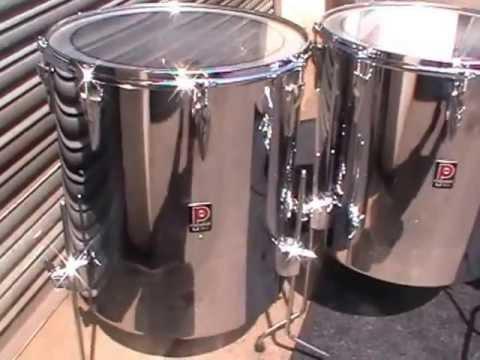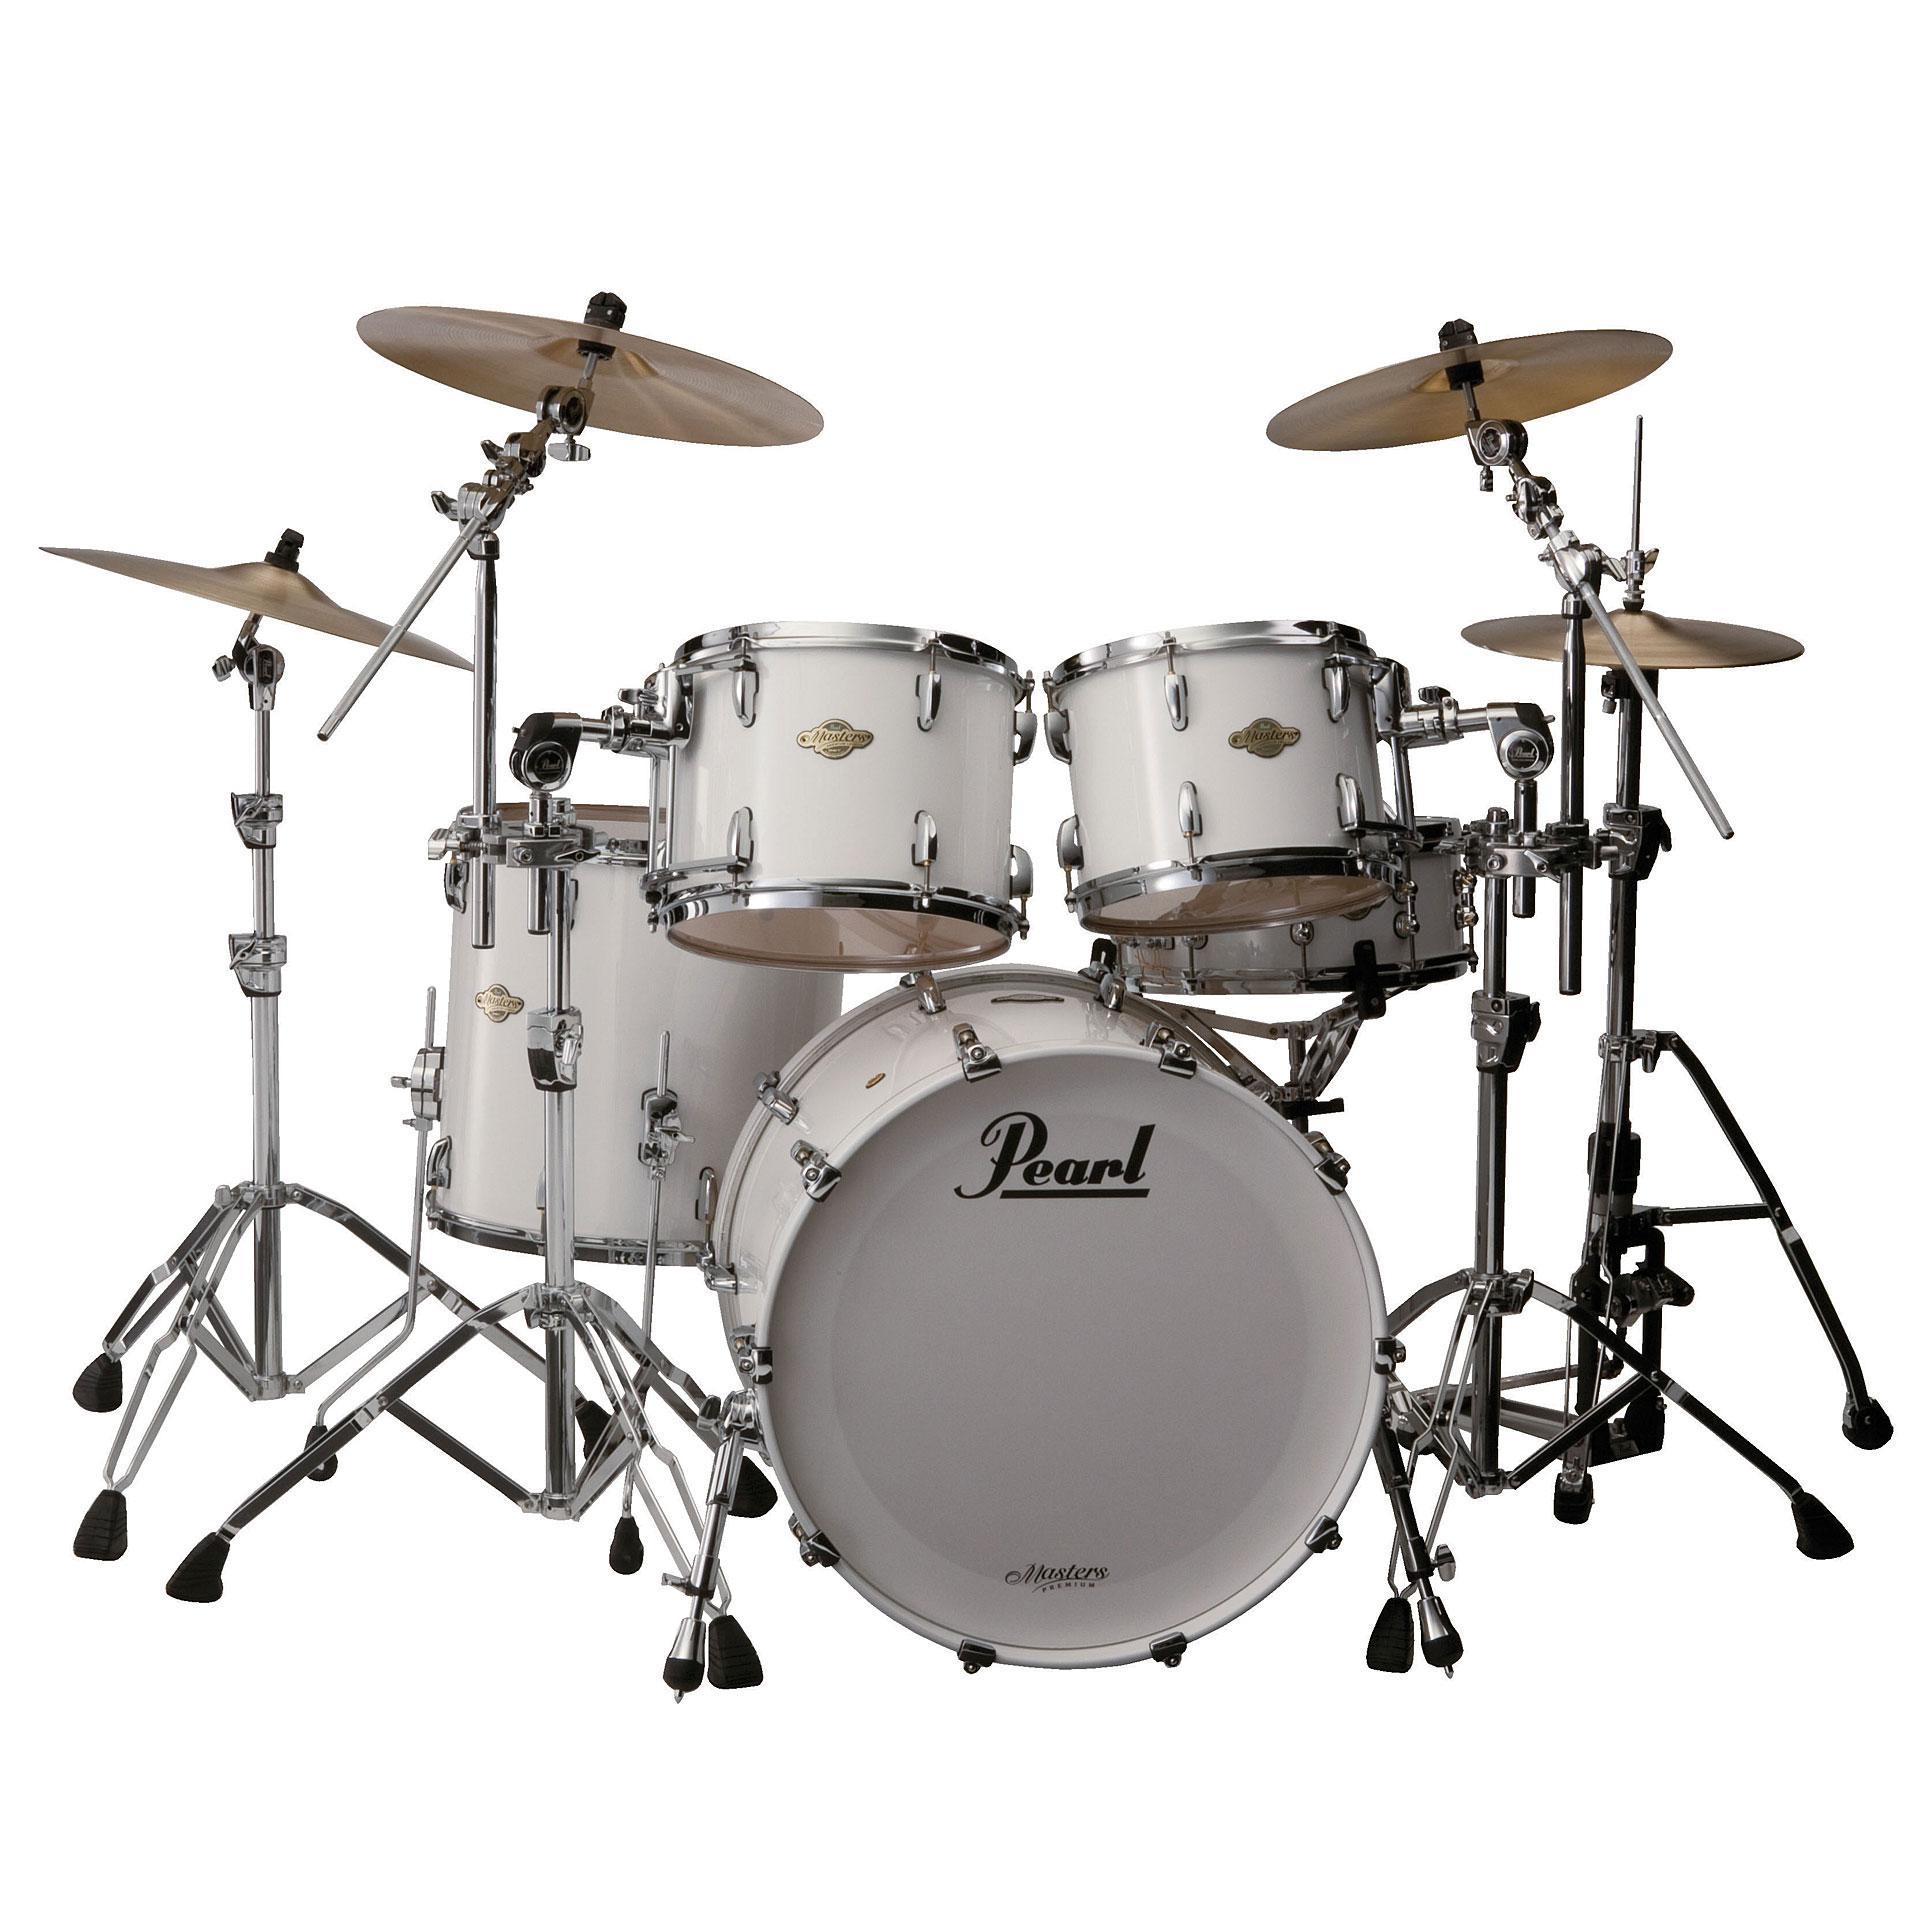The first image is the image on the left, the second image is the image on the right. Evaluate the accuracy of this statement regarding the images: "There is a man in one image, but not the other.". Is it true? Answer yes or no. No. The first image is the image on the left, the second image is the image on the right. Assess this claim about the two images: "The image to the left is a color image (not black & white) and features steel drums.". Correct or not? Answer yes or no. Yes. 